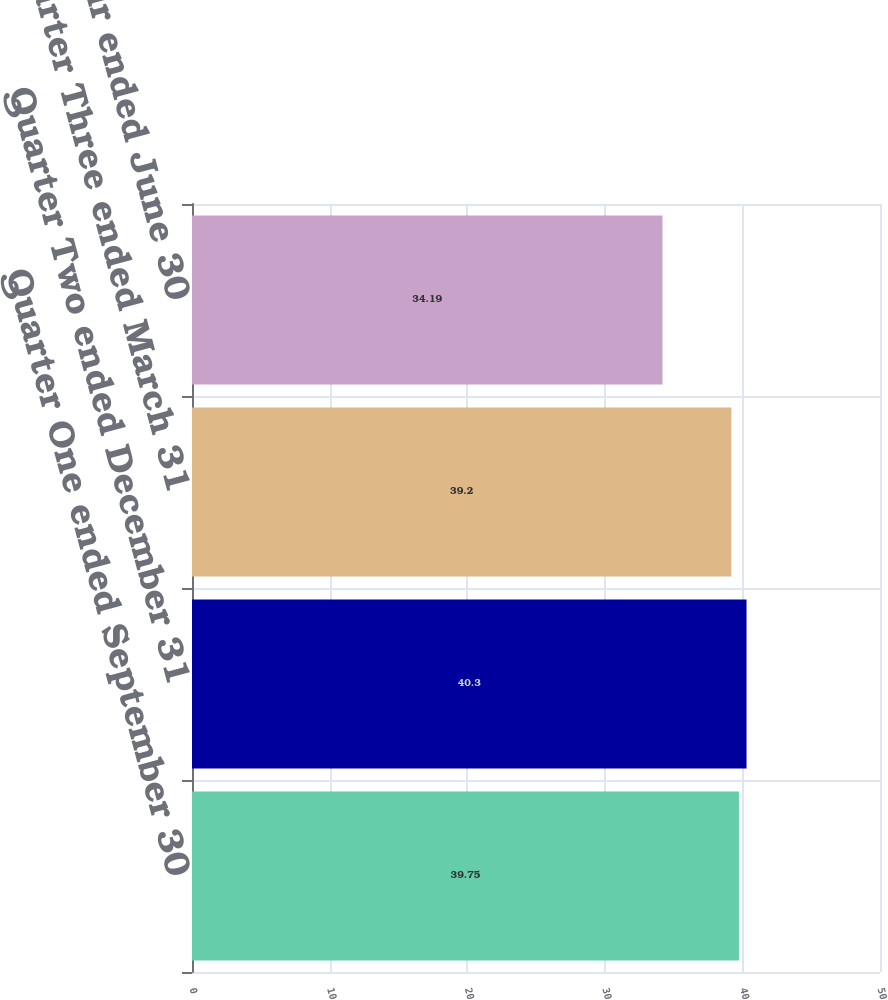<chart> <loc_0><loc_0><loc_500><loc_500><bar_chart><fcel>Quarter One ended September 30<fcel>Quarter Two ended December 31<fcel>Quarter Three ended March 31<fcel>Quarter Four ended June 30<nl><fcel>39.75<fcel>40.3<fcel>39.2<fcel>34.19<nl></chart> 